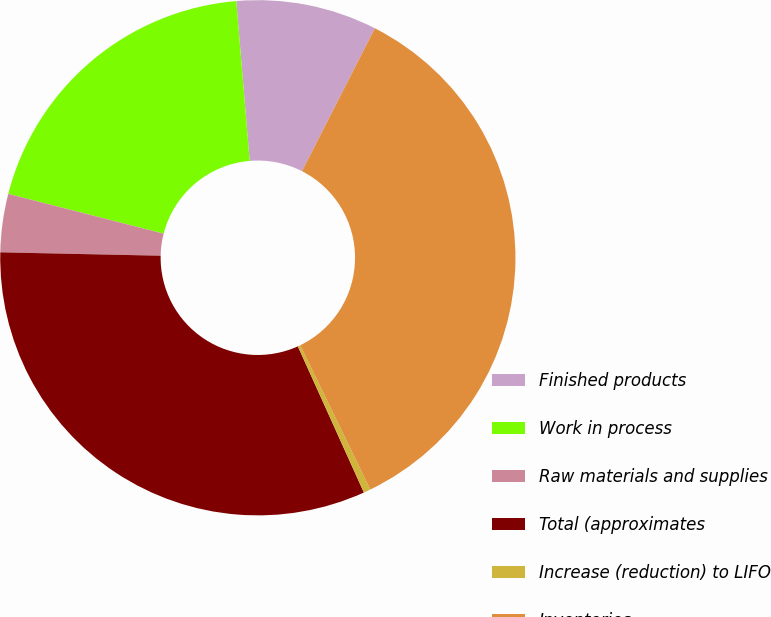<chart> <loc_0><loc_0><loc_500><loc_500><pie_chart><fcel>Finished products<fcel>Work in process<fcel>Raw materials and supplies<fcel>Total (approximates<fcel>Increase (reduction) to LIFO<fcel>Inventories<nl><fcel>8.84%<fcel>19.68%<fcel>3.65%<fcel>32.09%<fcel>0.44%<fcel>35.3%<nl></chart> 